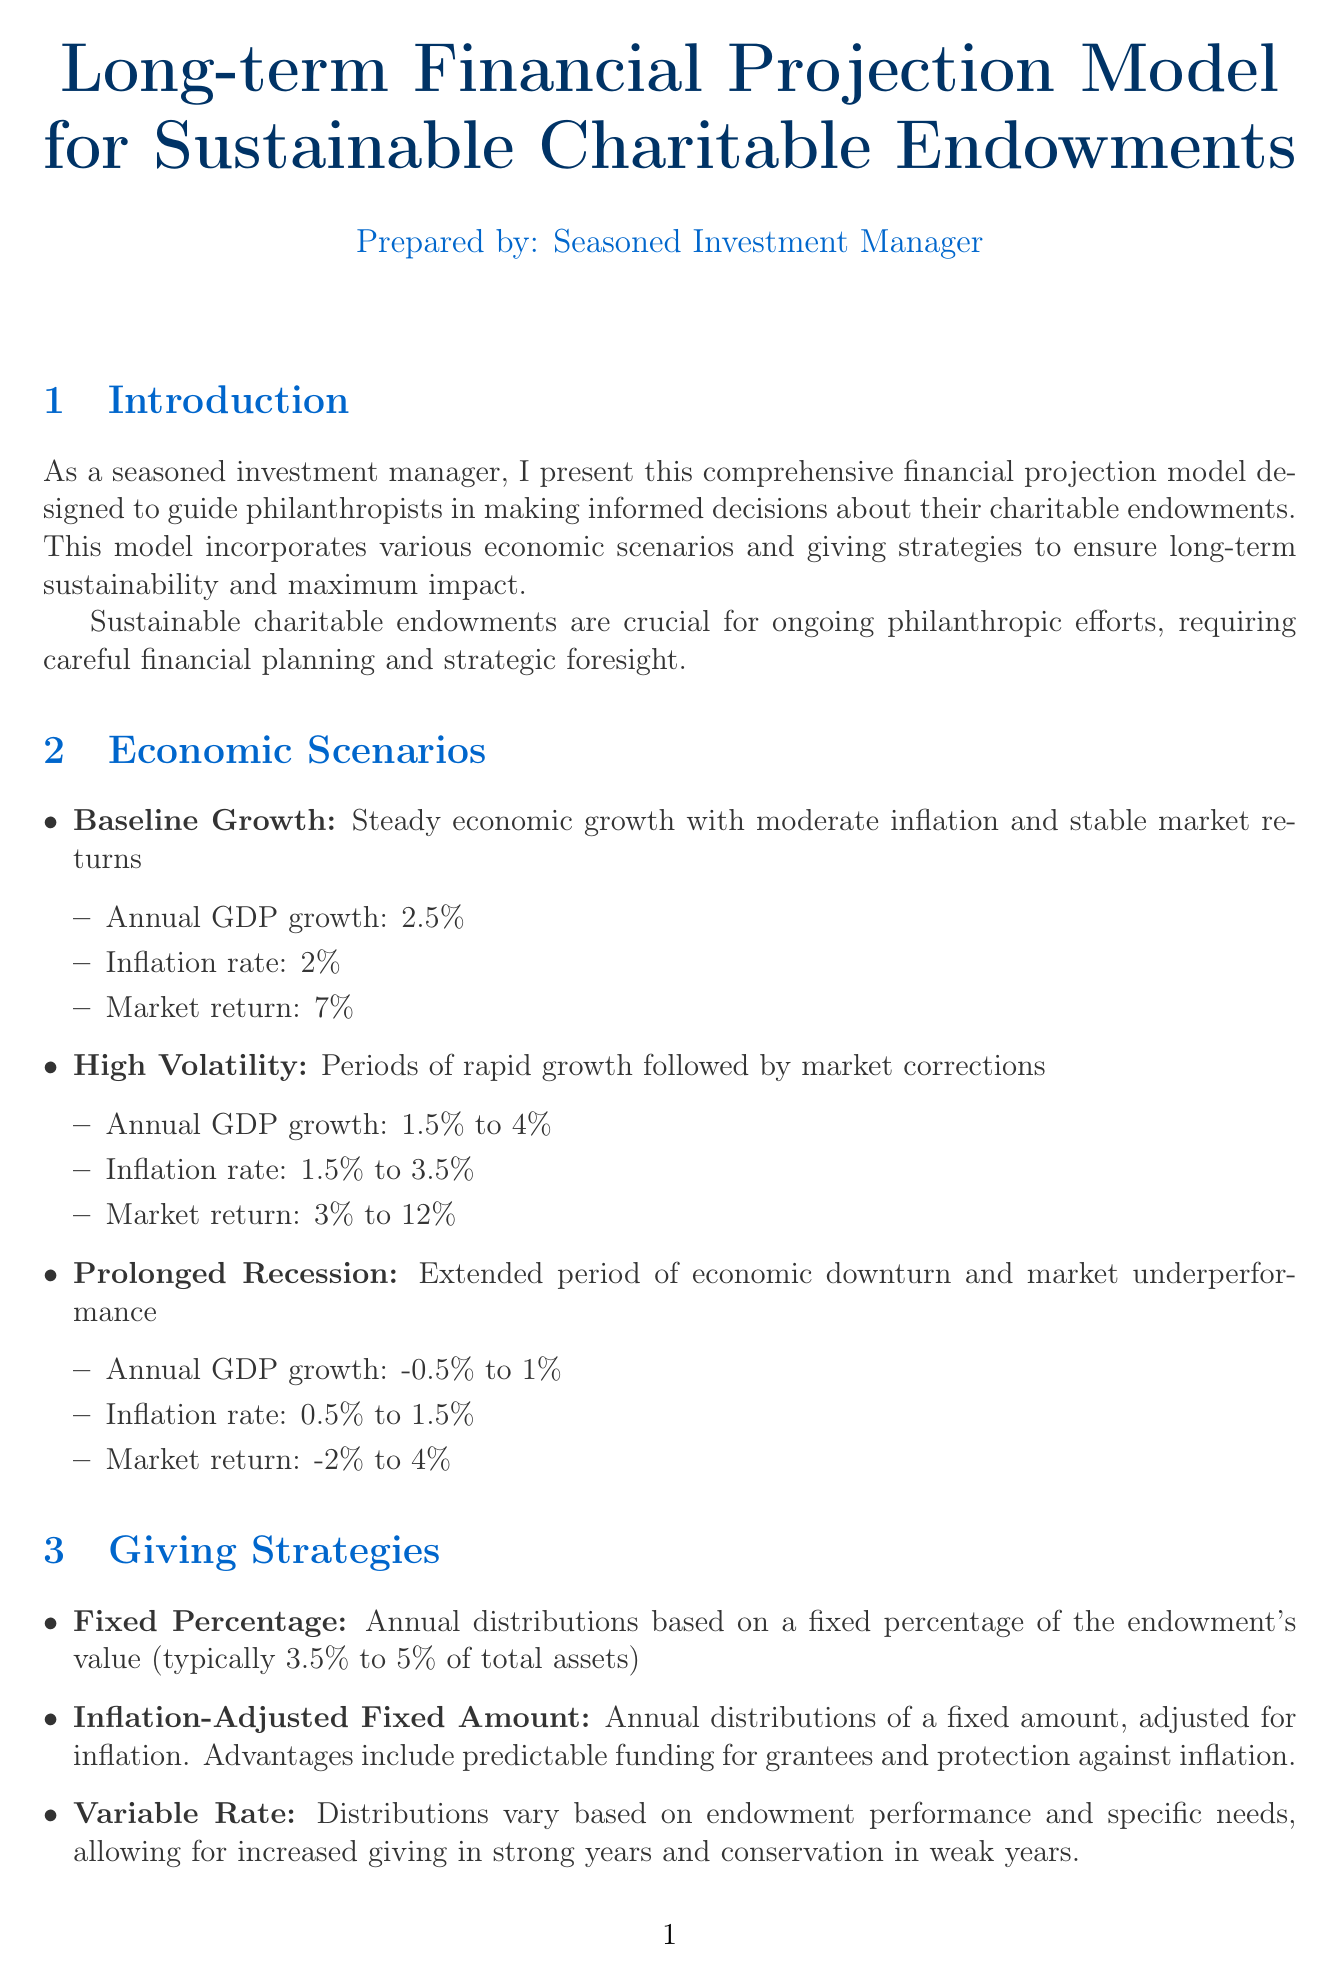What is the title of the report? The title of the report is explicitly stated at the top of the document.
Answer: Long-term Financial Projection Model for Sustainable Charitable Endowments What is the time horizon of the projection model? The document specifically mentions the time frame over which projections are made.
Answer: 30 years What is the annual GDP growth rate in the Baseline Growth scenario? The document outlines the assumptions for different economic scenarios, including GDP growth.
Answer: 2.5% What is the endowment size of the Ford Foundation? The document provides specific endowment amounts for notable foundations as part of case studies.
Answer: $16 billion What is one advantage of the Inflation-Adjusted Fixed Amount giving strategy? The document discusses benefits associated with different giving strategies, including this one.
Answer: Predictable funding for grantees What risk management strategy involves simulating extreme market conditions? The document describes different risk management components and strategies utilized in the projection model.
Answer: Stress testing What are the focus areas of the Bill & Melinda Gates Foundation? The document includes specific focus areas of various foundations as part of the case studies.
Answer: Global health, Education, Poverty alleviation What is the typical range for the Fixed Percentage giving strategy? The document indicates the standard range for this particular strategy in specific terms.
Answer: 3.5% to 5% of total assets What does the implementation guideline suggest about transparency? The document lists recommendations for endowment management, one of which relates to stakeholder engagement.
Answer: Maintain transparency with stakeholders about endowment management 